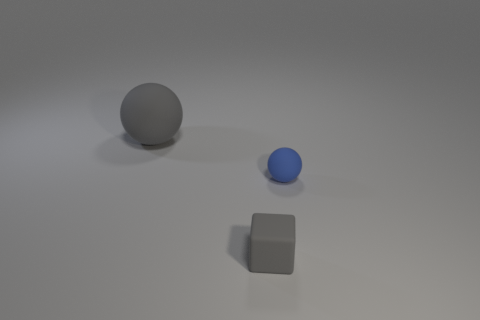Add 2 rubber balls. How many objects exist? 5 Subtract all spheres. How many objects are left? 1 Subtract all big things. Subtract all gray spheres. How many objects are left? 1 Add 2 gray things. How many gray things are left? 4 Add 2 gray matte spheres. How many gray matte spheres exist? 3 Subtract 0 purple balls. How many objects are left? 3 